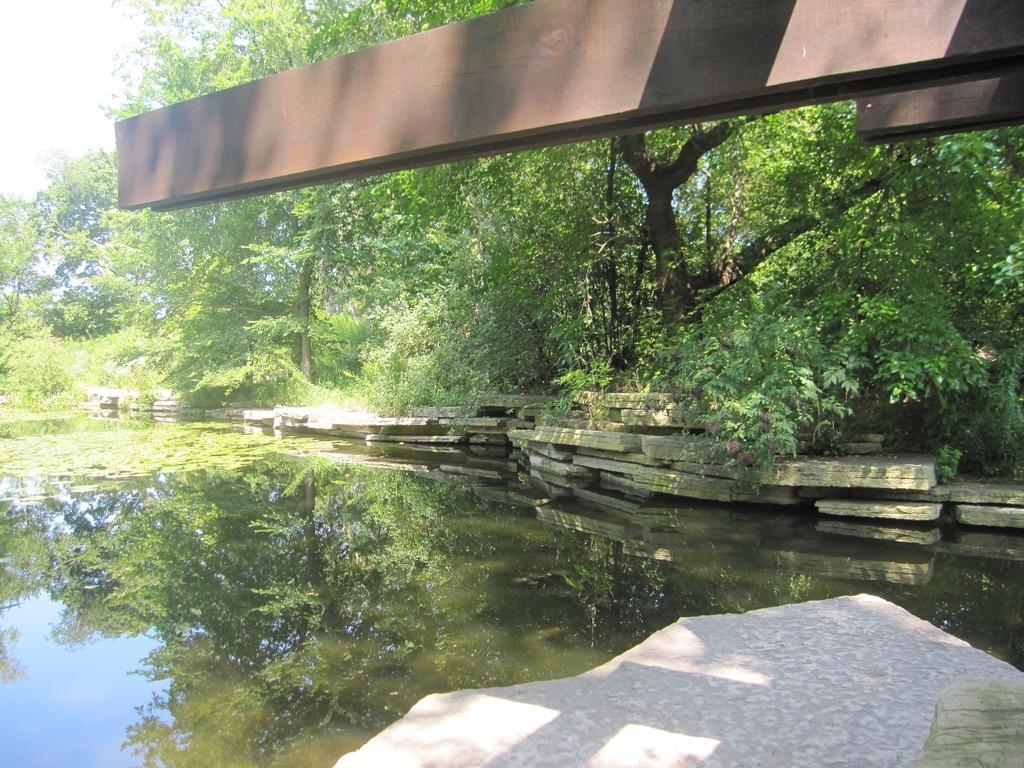In one or two sentences, can you explain what this image depicts? In the image we can see there is water and there are stone tiles on the water. There are iron poles on the top and there are lot of trees. There is reflection of trees in the water. 